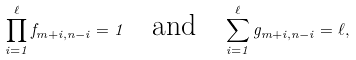<formula> <loc_0><loc_0><loc_500><loc_500>\prod _ { i = 1 } ^ { \ell } f _ { m + i , n - i } = 1 \quad \text {and} \quad \sum _ { i = 1 } ^ { \ell } g _ { m + i , n - i } = \ell ,</formula> 